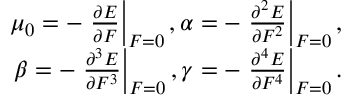<formula> <loc_0><loc_0><loc_500><loc_500>\begin{array} { r } { \mu _ { 0 } = - \frac { \partial E } { \partial F } \right | _ { F = 0 } , \alpha = - \frac { \partial ^ { 2 } E } { \partial F ^ { 2 } } \right | _ { F = 0 } , } \\ { \beta = - \frac { \partial ^ { 3 } E } { \partial F ^ { 3 } } \right | _ { F = 0 } , \gamma = - \frac { \partial ^ { 4 } E } { \partial F ^ { 4 } } \right | _ { F = 0 } . } \end{array}</formula> 